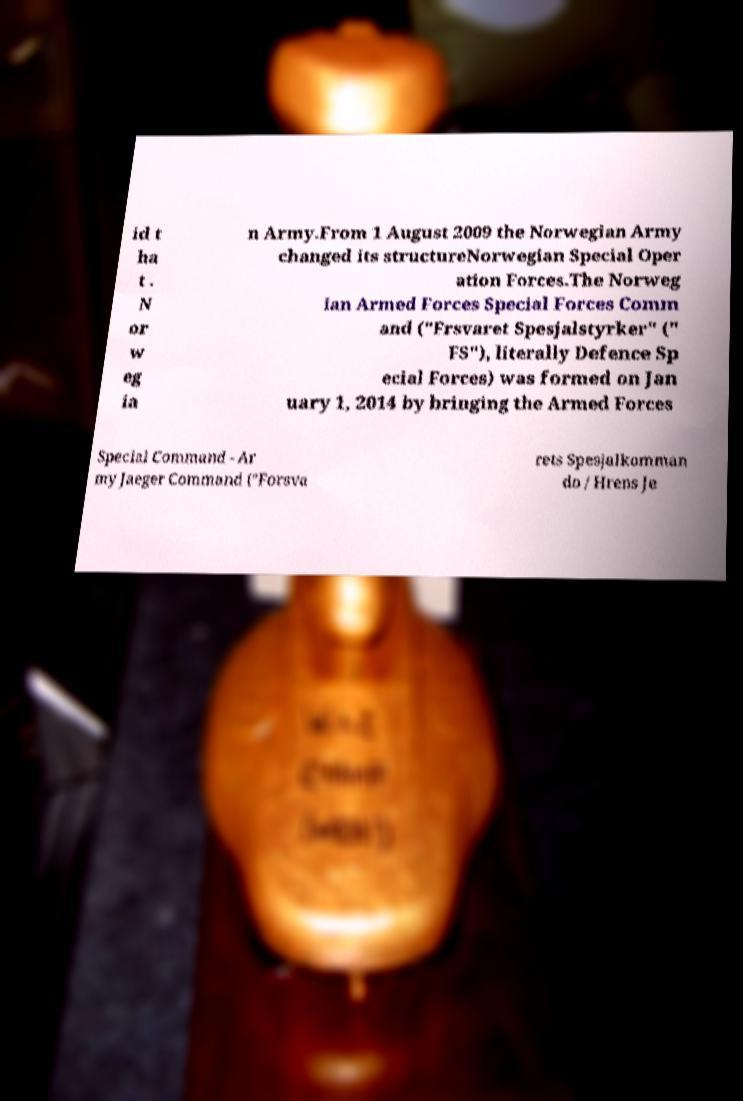I need the written content from this picture converted into text. Can you do that? id t ha t . N or w eg ia n Army.From 1 August 2009 the Norwegian Army changed its structureNorwegian Special Oper ation Forces.The Norweg ian Armed Forces Special Forces Comm and ("Frsvaret Spesjalstyrker" (" FS"), literally Defence Sp ecial Forces) was formed on Jan uary 1, 2014 by bringing the Armed Forces Special Command - Ar my Jaeger Command ("Forsva rets Spesjalkomman do / Hrens Je 